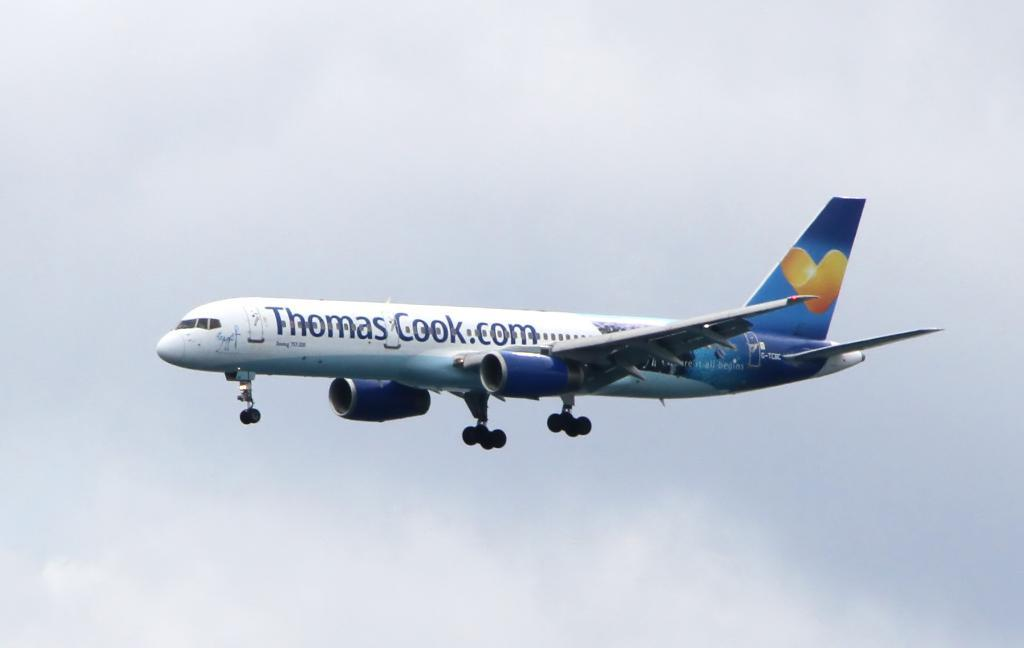Provide a one-sentence caption for the provided image. An airplane is in flight that has the name Thomas Cook on it. 